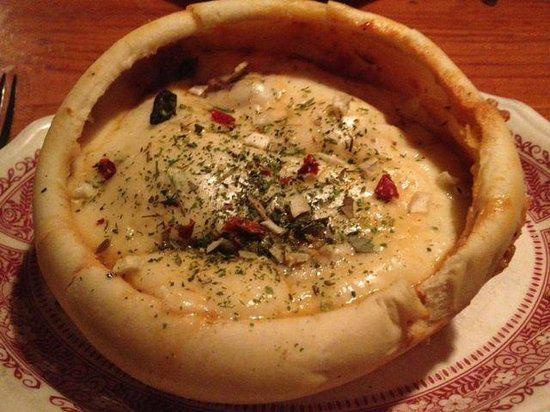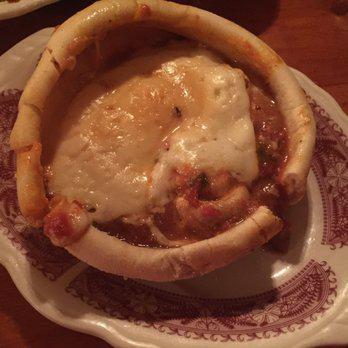The first image is the image on the left, the second image is the image on the right. For the images shown, is this caption "Each image shows exactly one item with melted cheese surrounded by a round crust on a plate with ornate dark red trim." true? Answer yes or no. Yes. 